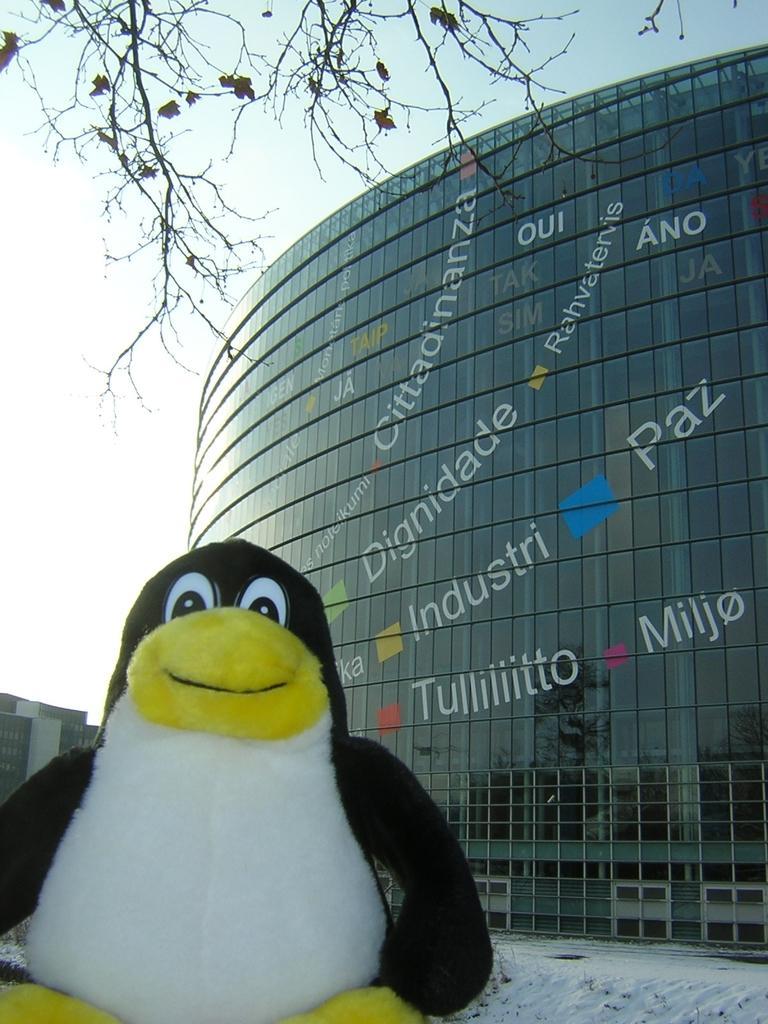In one or two sentences, can you explain what this image depicts? In the image we can see there is a toy of penguin standing on the ground and the ground is covered with snow. Behind there is a building and there is a tree on the top. 